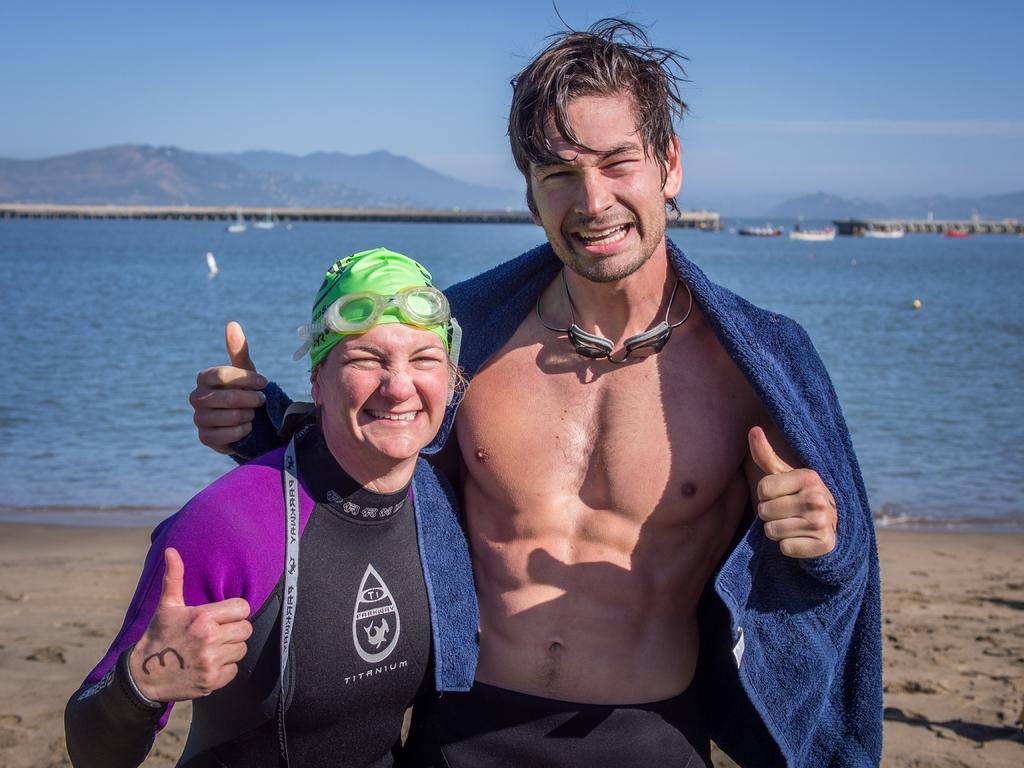In one or two sentences, can you explain what this image depicts? In this image we can see there are two persons standing on the ground and at the back there are boats on the water. And there is the bridge, mountains and the sky. 